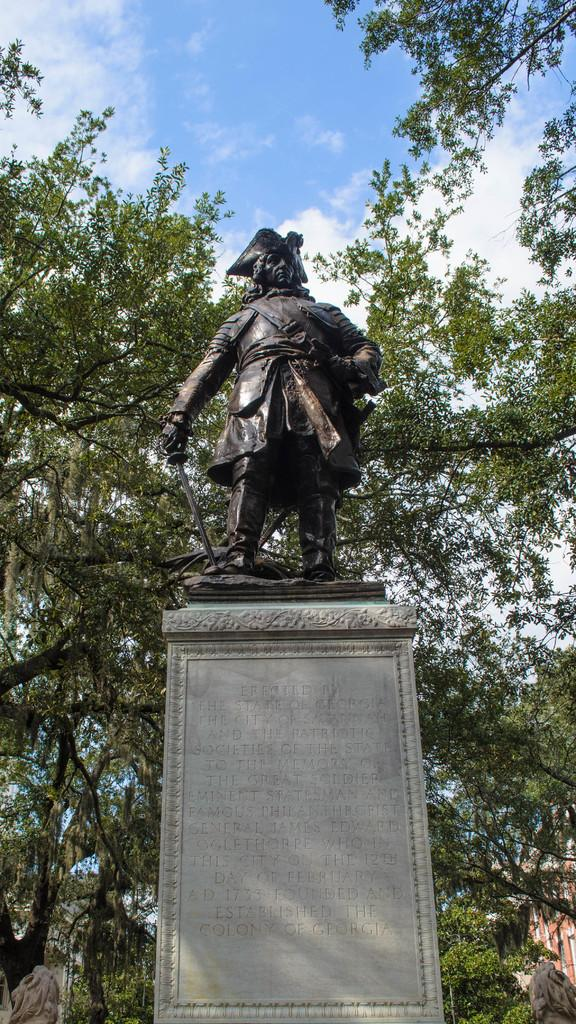What is the main subject of the image? There is a sculpture in the image. How is the sculpture positioned in relation to the pillar? The sculpture is standing on a pillar. What can be seen in the background of the image? There are trees, a building, and the sky visible in the background of the image. What type of waste is being recycled by the scarecrow in the image? There is no scarecrow or waste present in the image; it features a sculpture standing on a pillar. Can you tell me the age of the grandfather in the image? There is no grandfather present in the image; it features a sculpture standing on a pillar. 